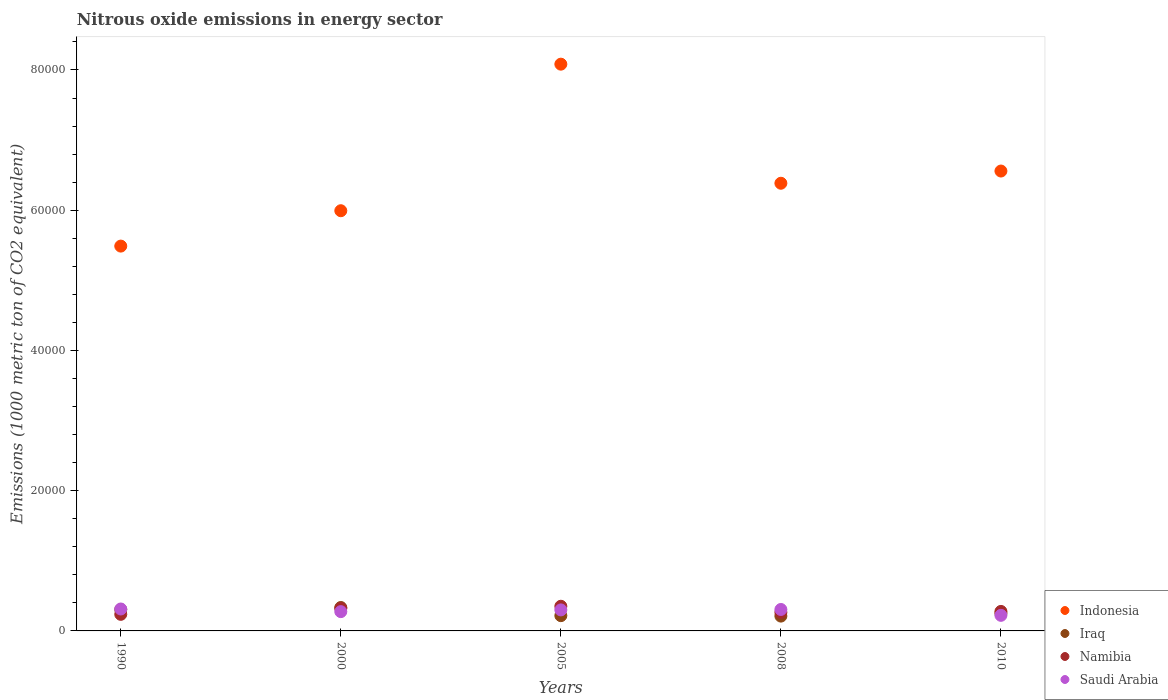Is the number of dotlines equal to the number of legend labels?
Make the answer very short. Yes. What is the amount of nitrous oxide emitted in Namibia in 2008?
Offer a terse response. 2645.5. Across all years, what is the maximum amount of nitrous oxide emitted in Iraq?
Your answer should be very brief. 3339.1. Across all years, what is the minimum amount of nitrous oxide emitted in Iraq?
Keep it short and to the point. 2113.2. What is the total amount of nitrous oxide emitted in Saudi Arabia in the graph?
Your answer should be compact. 1.42e+04. What is the difference between the amount of nitrous oxide emitted in Indonesia in 1990 and that in 2000?
Make the answer very short. -5044.7. What is the difference between the amount of nitrous oxide emitted in Indonesia in 2000 and the amount of nitrous oxide emitted in Iraq in 2008?
Make the answer very short. 5.78e+04. What is the average amount of nitrous oxide emitted in Indonesia per year?
Make the answer very short. 6.50e+04. In the year 2005, what is the difference between the amount of nitrous oxide emitted in Namibia and amount of nitrous oxide emitted in Iraq?
Offer a very short reply. 1340.8. What is the ratio of the amount of nitrous oxide emitted in Indonesia in 2000 to that in 2008?
Keep it short and to the point. 0.94. Is the difference between the amount of nitrous oxide emitted in Namibia in 2000 and 2010 greater than the difference between the amount of nitrous oxide emitted in Iraq in 2000 and 2010?
Offer a very short reply. No. What is the difference between the highest and the second highest amount of nitrous oxide emitted in Saudi Arabia?
Keep it short and to the point. 67.5. What is the difference between the highest and the lowest amount of nitrous oxide emitted in Indonesia?
Your answer should be compact. 2.59e+04. Is the sum of the amount of nitrous oxide emitted in Iraq in 2005 and 2010 greater than the maximum amount of nitrous oxide emitted in Indonesia across all years?
Make the answer very short. No. Is it the case that in every year, the sum of the amount of nitrous oxide emitted in Iraq and amount of nitrous oxide emitted in Namibia  is greater than the amount of nitrous oxide emitted in Saudi Arabia?
Provide a short and direct response. Yes. Does the amount of nitrous oxide emitted in Namibia monotonically increase over the years?
Your response must be concise. No. How many years are there in the graph?
Offer a terse response. 5. What is the difference between two consecutive major ticks on the Y-axis?
Provide a succinct answer. 2.00e+04. How are the legend labels stacked?
Offer a terse response. Vertical. What is the title of the graph?
Provide a short and direct response. Nitrous oxide emissions in energy sector. What is the label or title of the X-axis?
Make the answer very short. Years. What is the label or title of the Y-axis?
Offer a terse response. Emissions (1000 metric ton of CO2 equivalent). What is the Emissions (1000 metric ton of CO2 equivalent) of Indonesia in 1990?
Offer a terse response. 5.49e+04. What is the Emissions (1000 metric ton of CO2 equivalent) in Iraq in 1990?
Give a very brief answer. 3048.6. What is the Emissions (1000 metric ton of CO2 equivalent) in Namibia in 1990?
Provide a succinct answer. 2363.8. What is the Emissions (1000 metric ton of CO2 equivalent) in Saudi Arabia in 1990?
Your response must be concise. 3126.9. What is the Emissions (1000 metric ton of CO2 equivalent) in Indonesia in 2000?
Your answer should be compact. 5.99e+04. What is the Emissions (1000 metric ton of CO2 equivalent) in Iraq in 2000?
Provide a short and direct response. 3339.1. What is the Emissions (1000 metric ton of CO2 equivalent) in Namibia in 2000?
Give a very brief answer. 3218.7. What is the Emissions (1000 metric ton of CO2 equivalent) of Saudi Arabia in 2000?
Make the answer very short. 2750.6. What is the Emissions (1000 metric ton of CO2 equivalent) of Indonesia in 2005?
Offer a terse response. 8.08e+04. What is the Emissions (1000 metric ton of CO2 equivalent) in Iraq in 2005?
Your answer should be very brief. 2176. What is the Emissions (1000 metric ton of CO2 equivalent) in Namibia in 2005?
Offer a very short reply. 3516.8. What is the Emissions (1000 metric ton of CO2 equivalent) of Saudi Arabia in 2005?
Your answer should be very brief. 2996.3. What is the Emissions (1000 metric ton of CO2 equivalent) of Indonesia in 2008?
Make the answer very short. 6.38e+04. What is the Emissions (1000 metric ton of CO2 equivalent) of Iraq in 2008?
Your response must be concise. 2113.2. What is the Emissions (1000 metric ton of CO2 equivalent) of Namibia in 2008?
Offer a very short reply. 2645.5. What is the Emissions (1000 metric ton of CO2 equivalent) of Saudi Arabia in 2008?
Provide a short and direct response. 3059.4. What is the Emissions (1000 metric ton of CO2 equivalent) of Indonesia in 2010?
Your answer should be very brief. 6.56e+04. What is the Emissions (1000 metric ton of CO2 equivalent) in Iraq in 2010?
Ensure brevity in your answer.  2512.5. What is the Emissions (1000 metric ton of CO2 equivalent) of Namibia in 2010?
Provide a succinct answer. 2780.9. What is the Emissions (1000 metric ton of CO2 equivalent) of Saudi Arabia in 2010?
Your response must be concise. 2222.6. Across all years, what is the maximum Emissions (1000 metric ton of CO2 equivalent) in Indonesia?
Your response must be concise. 8.08e+04. Across all years, what is the maximum Emissions (1000 metric ton of CO2 equivalent) of Iraq?
Provide a short and direct response. 3339.1. Across all years, what is the maximum Emissions (1000 metric ton of CO2 equivalent) in Namibia?
Your answer should be compact. 3516.8. Across all years, what is the maximum Emissions (1000 metric ton of CO2 equivalent) of Saudi Arabia?
Provide a short and direct response. 3126.9. Across all years, what is the minimum Emissions (1000 metric ton of CO2 equivalent) of Indonesia?
Your answer should be compact. 5.49e+04. Across all years, what is the minimum Emissions (1000 metric ton of CO2 equivalent) of Iraq?
Your response must be concise. 2113.2. Across all years, what is the minimum Emissions (1000 metric ton of CO2 equivalent) of Namibia?
Your answer should be compact. 2363.8. Across all years, what is the minimum Emissions (1000 metric ton of CO2 equivalent) in Saudi Arabia?
Your answer should be very brief. 2222.6. What is the total Emissions (1000 metric ton of CO2 equivalent) in Indonesia in the graph?
Offer a terse response. 3.25e+05. What is the total Emissions (1000 metric ton of CO2 equivalent) of Iraq in the graph?
Offer a terse response. 1.32e+04. What is the total Emissions (1000 metric ton of CO2 equivalent) in Namibia in the graph?
Your answer should be compact. 1.45e+04. What is the total Emissions (1000 metric ton of CO2 equivalent) in Saudi Arabia in the graph?
Your answer should be very brief. 1.42e+04. What is the difference between the Emissions (1000 metric ton of CO2 equivalent) of Indonesia in 1990 and that in 2000?
Your answer should be very brief. -5044.7. What is the difference between the Emissions (1000 metric ton of CO2 equivalent) of Iraq in 1990 and that in 2000?
Offer a very short reply. -290.5. What is the difference between the Emissions (1000 metric ton of CO2 equivalent) in Namibia in 1990 and that in 2000?
Keep it short and to the point. -854.9. What is the difference between the Emissions (1000 metric ton of CO2 equivalent) of Saudi Arabia in 1990 and that in 2000?
Offer a very short reply. 376.3. What is the difference between the Emissions (1000 metric ton of CO2 equivalent) in Indonesia in 1990 and that in 2005?
Provide a short and direct response. -2.59e+04. What is the difference between the Emissions (1000 metric ton of CO2 equivalent) of Iraq in 1990 and that in 2005?
Your answer should be very brief. 872.6. What is the difference between the Emissions (1000 metric ton of CO2 equivalent) in Namibia in 1990 and that in 2005?
Your answer should be very brief. -1153. What is the difference between the Emissions (1000 metric ton of CO2 equivalent) in Saudi Arabia in 1990 and that in 2005?
Your answer should be compact. 130.6. What is the difference between the Emissions (1000 metric ton of CO2 equivalent) of Indonesia in 1990 and that in 2008?
Provide a short and direct response. -8962.8. What is the difference between the Emissions (1000 metric ton of CO2 equivalent) in Iraq in 1990 and that in 2008?
Your response must be concise. 935.4. What is the difference between the Emissions (1000 metric ton of CO2 equivalent) of Namibia in 1990 and that in 2008?
Give a very brief answer. -281.7. What is the difference between the Emissions (1000 metric ton of CO2 equivalent) of Saudi Arabia in 1990 and that in 2008?
Keep it short and to the point. 67.5. What is the difference between the Emissions (1000 metric ton of CO2 equivalent) of Indonesia in 1990 and that in 2010?
Your answer should be compact. -1.07e+04. What is the difference between the Emissions (1000 metric ton of CO2 equivalent) in Iraq in 1990 and that in 2010?
Make the answer very short. 536.1. What is the difference between the Emissions (1000 metric ton of CO2 equivalent) in Namibia in 1990 and that in 2010?
Provide a short and direct response. -417.1. What is the difference between the Emissions (1000 metric ton of CO2 equivalent) of Saudi Arabia in 1990 and that in 2010?
Give a very brief answer. 904.3. What is the difference between the Emissions (1000 metric ton of CO2 equivalent) in Indonesia in 2000 and that in 2005?
Offer a terse response. -2.09e+04. What is the difference between the Emissions (1000 metric ton of CO2 equivalent) in Iraq in 2000 and that in 2005?
Make the answer very short. 1163.1. What is the difference between the Emissions (1000 metric ton of CO2 equivalent) in Namibia in 2000 and that in 2005?
Ensure brevity in your answer.  -298.1. What is the difference between the Emissions (1000 metric ton of CO2 equivalent) in Saudi Arabia in 2000 and that in 2005?
Your answer should be very brief. -245.7. What is the difference between the Emissions (1000 metric ton of CO2 equivalent) in Indonesia in 2000 and that in 2008?
Ensure brevity in your answer.  -3918.1. What is the difference between the Emissions (1000 metric ton of CO2 equivalent) of Iraq in 2000 and that in 2008?
Your answer should be compact. 1225.9. What is the difference between the Emissions (1000 metric ton of CO2 equivalent) in Namibia in 2000 and that in 2008?
Offer a very short reply. 573.2. What is the difference between the Emissions (1000 metric ton of CO2 equivalent) in Saudi Arabia in 2000 and that in 2008?
Ensure brevity in your answer.  -308.8. What is the difference between the Emissions (1000 metric ton of CO2 equivalent) of Indonesia in 2000 and that in 2010?
Your answer should be very brief. -5659.3. What is the difference between the Emissions (1000 metric ton of CO2 equivalent) in Iraq in 2000 and that in 2010?
Your answer should be compact. 826.6. What is the difference between the Emissions (1000 metric ton of CO2 equivalent) of Namibia in 2000 and that in 2010?
Provide a short and direct response. 437.8. What is the difference between the Emissions (1000 metric ton of CO2 equivalent) in Saudi Arabia in 2000 and that in 2010?
Provide a succinct answer. 528. What is the difference between the Emissions (1000 metric ton of CO2 equivalent) of Indonesia in 2005 and that in 2008?
Make the answer very short. 1.70e+04. What is the difference between the Emissions (1000 metric ton of CO2 equivalent) in Iraq in 2005 and that in 2008?
Keep it short and to the point. 62.8. What is the difference between the Emissions (1000 metric ton of CO2 equivalent) of Namibia in 2005 and that in 2008?
Offer a very short reply. 871.3. What is the difference between the Emissions (1000 metric ton of CO2 equivalent) in Saudi Arabia in 2005 and that in 2008?
Make the answer very short. -63.1. What is the difference between the Emissions (1000 metric ton of CO2 equivalent) of Indonesia in 2005 and that in 2010?
Your response must be concise. 1.52e+04. What is the difference between the Emissions (1000 metric ton of CO2 equivalent) of Iraq in 2005 and that in 2010?
Offer a terse response. -336.5. What is the difference between the Emissions (1000 metric ton of CO2 equivalent) in Namibia in 2005 and that in 2010?
Your answer should be very brief. 735.9. What is the difference between the Emissions (1000 metric ton of CO2 equivalent) in Saudi Arabia in 2005 and that in 2010?
Give a very brief answer. 773.7. What is the difference between the Emissions (1000 metric ton of CO2 equivalent) of Indonesia in 2008 and that in 2010?
Your response must be concise. -1741.2. What is the difference between the Emissions (1000 metric ton of CO2 equivalent) of Iraq in 2008 and that in 2010?
Offer a terse response. -399.3. What is the difference between the Emissions (1000 metric ton of CO2 equivalent) in Namibia in 2008 and that in 2010?
Offer a terse response. -135.4. What is the difference between the Emissions (1000 metric ton of CO2 equivalent) in Saudi Arabia in 2008 and that in 2010?
Provide a succinct answer. 836.8. What is the difference between the Emissions (1000 metric ton of CO2 equivalent) of Indonesia in 1990 and the Emissions (1000 metric ton of CO2 equivalent) of Iraq in 2000?
Keep it short and to the point. 5.15e+04. What is the difference between the Emissions (1000 metric ton of CO2 equivalent) of Indonesia in 1990 and the Emissions (1000 metric ton of CO2 equivalent) of Namibia in 2000?
Provide a succinct answer. 5.17e+04. What is the difference between the Emissions (1000 metric ton of CO2 equivalent) in Indonesia in 1990 and the Emissions (1000 metric ton of CO2 equivalent) in Saudi Arabia in 2000?
Offer a terse response. 5.21e+04. What is the difference between the Emissions (1000 metric ton of CO2 equivalent) in Iraq in 1990 and the Emissions (1000 metric ton of CO2 equivalent) in Namibia in 2000?
Give a very brief answer. -170.1. What is the difference between the Emissions (1000 metric ton of CO2 equivalent) of Iraq in 1990 and the Emissions (1000 metric ton of CO2 equivalent) of Saudi Arabia in 2000?
Your answer should be very brief. 298. What is the difference between the Emissions (1000 metric ton of CO2 equivalent) in Namibia in 1990 and the Emissions (1000 metric ton of CO2 equivalent) in Saudi Arabia in 2000?
Your answer should be very brief. -386.8. What is the difference between the Emissions (1000 metric ton of CO2 equivalent) of Indonesia in 1990 and the Emissions (1000 metric ton of CO2 equivalent) of Iraq in 2005?
Your response must be concise. 5.27e+04. What is the difference between the Emissions (1000 metric ton of CO2 equivalent) of Indonesia in 1990 and the Emissions (1000 metric ton of CO2 equivalent) of Namibia in 2005?
Offer a terse response. 5.14e+04. What is the difference between the Emissions (1000 metric ton of CO2 equivalent) in Indonesia in 1990 and the Emissions (1000 metric ton of CO2 equivalent) in Saudi Arabia in 2005?
Make the answer very short. 5.19e+04. What is the difference between the Emissions (1000 metric ton of CO2 equivalent) in Iraq in 1990 and the Emissions (1000 metric ton of CO2 equivalent) in Namibia in 2005?
Provide a succinct answer. -468.2. What is the difference between the Emissions (1000 metric ton of CO2 equivalent) in Iraq in 1990 and the Emissions (1000 metric ton of CO2 equivalent) in Saudi Arabia in 2005?
Keep it short and to the point. 52.3. What is the difference between the Emissions (1000 metric ton of CO2 equivalent) of Namibia in 1990 and the Emissions (1000 metric ton of CO2 equivalent) of Saudi Arabia in 2005?
Your answer should be compact. -632.5. What is the difference between the Emissions (1000 metric ton of CO2 equivalent) in Indonesia in 1990 and the Emissions (1000 metric ton of CO2 equivalent) in Iraq in 2008?
Offer a very short reply. 5.28e+04. What is the difference between the Emissions (1000 metric ton of CO2 equivalent) of Indonesia in 1990 and the Emissions (1000 metric ton of CO2 equivalent) of Namibia in 2008?
Provide a short and direct response. 5.22e+04. What is the difference between the Emissions (1000 metric ton of CO2 equivalent) in Indonesia in 1990 and the Emissions (1000 metric ton of CO2 equivalent) in Saudi Arabia in 2008?
Your response must be concise. 5.18e+04. What is the difference between the Emissions (1000 metric ton of CO2 equivalent) in Iraq in 1990 and the Emissions (1000 metric ton of CO2 equivalent) in Namibia in 2008?
Ensure brevity in your answer.  403.1. What is the difference between the Emissions (1000 metric ton of CO2 equivalent) in Namibia in 1990 and the Emissions (1000 metric ton of CO2 equivalent) in Saudi Arabia in 2008?
Give a very brief answer. -695.6. What is the difference between the Emissions (1000 metric ton of CO2 equivalent) of Indonesia in 1990 and the Emissions (1000 metric ton of CO2 equivalent) of Iraq in 2010?
Offer a terse response. 5.24e+04. What is the difference between the Emissions (1000 metric ton of CO2 equivalent) of Indonesia in 1990 and the Emissions (1000 metric ton of CO2 equivalent) of Namibia in 2010?
Your answer should be very brief. 5.21e+04. What is the difference between the Emissions (1000 metric ton of CO2 equivalent) in Indonesia in 1990 and the Emissions (1000 metric ton of CO2 equivalent) in Saudi Arabia in 2010?
Provide a succinct answer. 5.27e+04. What is the difference between the Emissions (1000 metric ton of CO2 equivalent) of Iraq in 1990 and the Emissions (1000 metric ton of CO2 equivalent) of Namibia in 2010?
Ensure brevity in your answer.  267.7. What is the difference between the Emissions (1000 metric ton of CO2 equivalent) of Iraq in 1990 and the Emissions (1000 metric ton of CO2 equivalent) of Saudi Arabia in 2010?
Your answer should be very brief. 826. What is the difference between the Emissions (1000 metric ton of CO2 equivalent) in Namibia in 1990 and the Emissions (1000 metric ton of CO2 equivalent) in Saudi Arabia in 2010?
Your answer should be compact. 141.2. What is the difference between the Emissions (1000 metric ton of CO2 equivalent) in Indonesia in 2000 and the Emissions (1000 metric ton of CO2 equivalent) in Iraq in 2005?
Keep it short and to the point. 5.78e+04. What is the difference between the Emissions (1000 metric ton of CO2 equivalent) in Indonesia in 2000 and the Emissions (1000 metric ton of CO2 equivalent) in Namibia in 2005?
Keep it short and to the point. 5.64e+04. What is the difference between the Emissions (1000 metric ton of CO2 equivalent) of Indonesia in 2000 and the Emissions (1000 metric ton of CO2 equivalent) of Saudi Arabia in 2005?
Offer a very short reply. 5.69e+04. What is the difference between the Emissions (1000 metric ton of CO2 equivalent) in Iraq in 2000 and the Emissions (1000 metric ton of CO2 equivalent) in Namibia in 2005?
Keep it short and to the point. -177.7. What is the difference between the Emissions (1000 metric ton of CO2 equivalent) of Iraq in 2000 and the Emissions (1000 metric ton of CO2 equivalent) of Saudi Arabia in 2005?
Your answer should be very brief. 342.8. What is the difference between the Emissions (1000 metric ton of CO2 equivalent) in Namibia in 2000 and the Emissions (1000 metric ton of CO2 equivalent) in Saudi Arabia in 2005?
Offer a terse response. 222.4. What is the difference between the Emissions (1000 metric ton of CO2 equivalent) of Indonesia in 2000 and the Emissions (1000 metric ton of CO2 equivalent) of Iraq in 2008?
Ensure brevity in your answer.  5.78e+04. What is the difference between the Emissions (1000 metric ton of CO2 equivalent) in Indonesia in 2000 and the Emissions (1000 metric ton of CO2 equivalent) in Namibia in 2008?
Offer a terse response. 5.73e+04. What is the difference between the Emissions (1000 metric ton of CO2 equivalent) of Indonesia in 2000 and the Emissions (1000 metric ton of CO2 equivalent) of Saudi Arabia in 2008?
Your answer should be compact. 5.69e+04. What is the difference between the Emissions (1000 metric ton of CO2 equivalent) in Iraq in 2000 and the Emissions (1000 metric ton of CO2 equivalent) in Namibia in 2008?
Give a very brief answer. 693.6. What is the difference between the Emissions (1000 metric ton of CO2 equivalent) of Iraq in 2000 and the Emissions (1000 metric ton of CO2 equivalent) of Saudi Arabia in 2008?
Provide a short and direct response. 279.7. What is the difference between the Emissions (1000 metric ton of CO2 equivalent) of Namibia in 2000 and the Emissions (1000 metric ton of CO2 equivalent) of Saudi Arabia in 2008?
Your response must be concise. 159.3. What is the difference between the Emissions (1000 metric ton of CO2 equivalent) of Indonesia in 2000 and the Emissions (1000 metric ton of CO2 equivalent) of Iraq in 2010?
Your answer should be compact. 5.74e+04. What is the difference between the Emissions (1000 metric ton of CO2 equivalent) of Indonesia in 2000 and the Emissions (1000 metric ton of CO2 equivalent) of Namibia in 2010?
Your answer should be compact. 5.71e+04. What is the difference between the Emissions (1000 metric ton of CO2 equivalent) of Indonesia in 2000 and the Emissions (1000 metric ton of CO2 equivalent) of Saudi Arabia in 2010?
Ensure brevity in your answer.  5.77e+04. What is the difference between the Emissions (1000 metric ton of CO2 equivalent) in Iraq in 2000 and the Emissions (1000 metric ton of CO2 equivalent) in Namibia in 2010?
Ensure brevity in your answer.  558.2. What is the difference between the Emissions (1000 metric ton of CO2 equivalent) in Iraq in 2000 and the Emissions (1000 metric ton of CO2 equivalent) in Saudi Arabia in 2010?
Offer a terse response. 1116.5. What is the difference between the Emissions (1000 metric ton of CO2 equivalent) of Namibia in 2000 and the Emissions (1000 metric ton of CO2 equivalent) of Saudi Arabia in 2010?
Your response must be concise. 996.1. What is the difference between the Emissions (1000 metric ton of CO2 equivalent) of Indonesia in 2005 and the Emissions (1000 metric ton of CO2 equivalent) of Iraq in 2008?
Your answer should be very brief. 7.87e+04. What is the difference between the Emissions (1000 metric ton of CO2 equivalent) in Indonesia in 2005 and the Emissions (1000 metric ton of CO2 equivalent) in Namibia in 2008?
Your answer should be very brief. 7.82e+04. What is the difference between the Emissions (1000 metric ton of CO2 equivalent) in Indonesia in 2005 and the Emissions (1000 metric ton of CO2 equivalent) in Saudi Arabia in 2008?
Offer a very short reply. 7.78e+04. What is the difference between the Emissions (1000 metric ton of CO2 equivalent) in Iraq in 2005 and the Emissions (1000 metric ton of CO2 equivalent) in Namibia in 2008?
Offer a terse response. -469.5. What is the difference between the Emissions (1000 metric ton of CO2 equivalent) in Iraq in 2005 and the Emissions (1000 metric ton of CO2 equivalent) in Saudi Arabia in 2008?
Provide a succinct answer. -883.4. What is the difference between the Emissions (1000 metric ton of CO2 equivalent) of Namibia in 2005 and the Emissions (1000 metric ton of CO2 equivalent) of Saudi Arabia in 2008?
Keep it short and to the point. 457.4. What is the difference between the Emissions (1000 metric ton of CO2 equivalent) of Indonesia in 2005 and the Emissions (1000 metric ton of CO2 equivalent) of Iraq in 2010?
Your answer should be very brief. 7.83e+04. What is the difference between the Emissions (1000 metric ton of CO2 equivalent) of Indonesia in 2005 and the Emissions (1000 metric ton of CO2 equivalent) of Namibia in 2010?
Your answer should be compact. 7.80e+04. What is the difference between the Emissions (1000 metric ton of CO2 equivalent) in Indonesia in 2005 and the Emissions (1000 metric ton of CO2 equivalent) in Saudi Arabia in 2010?
Make the answer very short. 7.86e+04. What is the difference between the Emissions (1000 metric ton of CO2 equivalent) of Iraq in 2005 and the Emissions (1000 metric ton of CO2 equivalent) of Namibia in 2010?
Offer a terse response. -604.9. What is the difference between the Emissions (1000 metric ton of CO2 equivalent) of Iraq in 2005 and the Emissions (1000 metric ton of CO2 equivalent) of Saudi Arabia in 2010?
Keep it short and to the point. -46.6. What is the difference between the Emissions (1000 metric ton of CO2 equivalent) in Namibia in 2005 and the Emissions (1000 metric ton of CO2 equivalent) in Saudi Arabia in 2010?
Provide a succinct answer. 1294.2. What is the difference between the Emissions (1000 metric ton of CO2 equivalent) of Indonesia in 2008 and the Emissions (1000 metric ton of CO2 equivalent) of Iraq in 2010?
Your answer should be compact. 6.13e+04. What is the difference between the Emissions (1000 metric ton of CO2 equivalent) of Indonesia in 2008 and the Emissions (1000 metric ton of CO2 equivalent) of Namibia in 2010?
Provide a short and direct response. 6.11e+04. What is the difference between the Emissions (1000 metric ton of CO2 equivalent) in Indonesia in 2008 and the Emissions (1000 metric ton of CO2 equivalent) in Saudi Arabia in 2010?
Your response must be concise. 6.16e+04. What is the difference between the Emissions (1000 metric ton of CO2 equivalent) in Iraq in 2008 and the Emissions (1000 metric ton of CO2 equivalent) in Namibia in 2010?
Keep it short and to the point. -667.7. What is the difference between the Emissions (1000 metric ton of CO2 equivalent) in Iraq in 2008 and the Emissions (1000 metric ton of CO2 equivalent) in Saudi Arabia in 2010?
Your answer should be compact. -109.4. What is the difference between the Emissions (1000 metric ton of CO2 equivalent) in Namibia in 2008 and the Emissions (1000 metric ton of CO2 equivalent) in Saudi Arabia in 2010?
Your response must be concise. 422.9. What is the average Emissions (1000 metric ton of CO2 equivalent) of Indonesia per year?
Keep it short and to the point. 6.50e+04. What is the average Emissions (1000 metric ton of CO2 equivalent) in Iraq per year?
Your answer should be compact. 2637.88. What is the average Emissions (1000 metric ton of CO2 equivalent) in Namibia per year?
Provide a succinct answer. 2905.14. What is the average Emissions (1000 metric ton of CO2 equivalent) in Saudi Arabia per year?
Your answer should be compact. 2831.16. In the year 1990, what is the difference between the Emissions (1000 metric ton of CO2 equivalent) in Indonesia and Emissions (1000 metric ton of CO2 equivalent) in Iraq?
Your response must be concise. 5.18e+04. In the year 1990, what is the difference between the Emissions (1000 metric ton of CO2 equivalent) of Indonesia and Emissions (1000 metric ton of CO2 equivalent) of Namibia?
Give a very brief answer. 5.25e+04. In the year 1990, what is the difference between the Emissions (1000 metric ton of CO2 equivalent) of Indonesia and Emissions (1000 metric ton of CO2 equivalent) of Saudi Arabia?
Provide a short and direct response. 5.18e+04. In the year 1990, what is the difference between the Emissions (1000 metric ton of CO2 equivalent) of Iraq and Emissions (1000 metric ton of CO2 equivalent) of Namibia?
Provide a short and direct response. 684.8. In the year 1990, what is the difference between the Emissions (1000 metric ton of CO2 equivalent) in Iraq and Emissions (1000 metric ton of CO2 equivalent) in Saudi Arabia?
Make the answer very short. -78.3. In the year 1990, what is the difference between the Emissions (1000 metric ton of CO2 equivalent) in Namibia and Emissions (1000 metric ton of CO2 equivalent) in Saudi Arabia?
Give a very brief answer. -763.1. In the year 2000, what is the difference between the Emissions (1000 metric ton of CO2 equivalent) of Indonesia and Emissions (1000 metric ton of CO2 equivalent) of Iraq?
Your answer should be compact. 5.66e+04. In the year 2000, what is the difference between the Emissions (1000 metric ton of CO2 equivalent) in Indonesia and Emissions (1000 metric ton of CO2 equivalent) in Namibia?
Ensure brevity in your answer.  5.67e+04. In the year 2000, what is the difference between the Emissions (1000 metric ton of CO2 equivalent) of Indonesia and Emissions (1000 metric ton of CO2 equivalent) of Saudi Arabia?
Give a very brief answer. 5.72e+04. In the year 2000, what is the difference between the Emissions (1000 metric ton of CO2 equivalent) in Iraq and Emissions (1000 metric ton of CO2 equivalent) in Namibia?
Provide a short and direct response. 120.4. In the year 2000, what is the difference between the Emissions (1000 metric ton of CO2 equivalent) of Iraq and Emissions (1000 metric ton of CO2 equivalent) of Saudi Arabia?
Offer a very short reply. 588.5. In the year 2000, what is the difference between the Emissions (1000 metric ton of CO2 equivalent) of Namibia and Emissions (1000 metric ton of CO2 equivalent) of Saudi Arabia?
Offer a very short reply. 468.1. In the year 2005, what is the difference between the Emissions (1000 metric ton of CO2 equivalent) of Indonesia and Emissions (1000 metric ton of CO2 equivalent) of Iraq?
Your answer should be very brief. 7.87e+04. In the year 2005, what is the difference between the Emissions (1000 metric ton of CO2 equivalent) in Indonesia and Emissions (1000 metric ton of CO2 equivalent) in Namibia?
Offer a very short reply. 7.73e+04. In the year 2005, what is the difference between the Emissions (1000 metric ton of CO2 equivalent) in Indonesia and Emissions (1000 metric ton of CO2 equivalent) in Saudi Arabia?
Keep it short and to the point. 7.78e+04. In the year 2005, what is the difference between the Emissions (1000 metric ton of CO2 equivalent) of Iraq and Emissions (1000 metric ton of CO2 equivalent) of Namibia?
Offer a terse response. -1340.8. In the year 2005, what is the difference between the Emissions (1000 metric ton of CO2 equivalent) of Iraq and Emissions (1000 metric ton of CO2 equivalent) of Saudi Arabia?
Ensure brevity in your answer.  -820.3. In the year 2005, what is the difference between the Emissions (1000 metric ton of CO2 equivalent) in Namibia and Emissions (1000 metric ton of CO2 equivalent) in Saudi Arabia?
Your answer should be compact. 520.5. In the year 2008, what is the difference between the Emissions (1000 metric ton of CO2 equivalent) in Indonesia and Emissions (1000 metric ton of CO2 equivalent) in Iraq?
Offer a very short reply. 6.17e+04. In the year 2008, what is the difference between the Emissions (1000 metric ton of CO2 equivalent) of Indonesia and Emissions (1000 metric ton of CO2 equivalent) of Namibia?
Offer a terse response. 6.12e+04. In the year 2008, what is the difference between the Emissions (1000 metric ton of CO2 equivalent) in Indonesia and Emissions (1000 metric ton of CO2 equivalent) in Saudi Arabia?
Make the answer very short. 6.08e+04. In the year 2008, what is the difference between the Emissions (1000 metric ton of CO2 equivalent) in Iraq and Emissions (1000 metric ton of CO2 equivalent) in Namibia?
Provide a short and direct response. -532.3. In the year 2008, what is the difference between the Emissions (1000 metric ton of CO2 equivalent) in Iraq and Emissions (1000 metric ton of CO2 equivalent) in Saudi Arabia?
Your answer should be very brief. -946.2. In the year 2008, what is the difference between the Emissions (1000 metric ton of CO2 equivalent) in Namibia and Emissions (1000 metric ton of CO2 equivalent) in Saudi Arabia?
Make the answer very short. -413.9. In the year 2010, what is the difference between the Emissions (1000 metric ton of CO2 equivalent) of Indonesia and Emissions (1000 metric ton of CO2 equivalent) of Iraq?
Provide a succinct answer. 6.31e+04. In the year 2010, what is the difference between the Emissions (1000 metric ton of CO2 equivalent) in Indonesia and Emissions (1000 metric ton of CO2 equivalent) in Namibia?
Offer a very short reply. 6.28e+04. In the year 2010, what is the difference between the Emissions (1000 metric ton of CO2 equivalent) in Indonesia and Emissions (1000 metric ton of CO2 equivalent) in Saudi Arabia?
Give a very brief answer. 6.34e+04. In the year 2010, what is the difference between the Emissions (1000 metric ton of CO2 equivalent) of Iraq and Emissions (1000 metric ton of CO2 equivalent) of Namibia?
Ensure brevity in your answer.  -268.4. In the year 2010, what is the difference between the Emissions (1000 metric ton of CO2 equivalent) of Iraq and Emissions (1000 metric ton of CO2 equivalent) of Saudi Arabia?
Offer a terse response. 289.9. In the year 2010, what is the difference between the Emissions (1000 metric ton of CO2 equivalent) in Namibia and Emissions (1000 metric ton of CO2 equivalent) in Saudi Arabia?
Your answer should be very brief. 558.3. What is the ratio of the Emissions (1000 metric ton of CO2 equivalent) in Indonesia in 1990 to that in 2000?
Make the answer very short. 0.92. What is the ratio of the Emissions (1000 metric ton of CO2 equivalent) in Iraq in 1990 to that in 2000?
Offer a terse response. 0.91. What is the ratio of the Emissions (1000 metric ton of CO2 equivalent) of Namibia in 1990 to that in 2000?
Your answer should be very brief. 0.73. What is the ratio of the Emissions (1000 metric ton of CO2 equivalent) in Saudi Arabia in 1990 to that in 2000?
Make the answer very short. 1.14. What is the ratio of the Emissions (1000 metric ton of CO2 equivalent) of Indonesia in 1990 to that in 2005?
Offer a very short reply. 0.68. What is the ratio of the Emissions (1000 metric ton of CO2 equivalent) in Iraq in 1990 to that in 2005?
Keep it short and to the point. 1.4. What is the ratio of the Emissions (1000 metric ton of CO2 equivalent) in Namibia in 1990 to that in 2005?
Offer a terse response. 0.67. What is the ratio of the Emissions (1000 metric ton of CO2 equivalent) in Saudi Arabia in 1990 to that in 2005?
Your answer should be very brief. 1.04. What is the ratio of the Emissions (1000 metric ton of CO2 equivalent) in Indonesia in 1990 to that in 2008?
Offer a terse response. 0.86. What is the ratio of the Emissions (1000 metric ton of CO2 equivalent) in Iraq in 1990 to that in 2008?
Keep it short and to the point. 1.44. What is the ratio of the Emissions (1000 metric ton of CO2 equivalent) of Namibia in 1990 to that in 2008?
Provide a succinct answer. 0.89. What is the ratio of the Emissions (1000 metric ton of CO2 equivalent) of Saudi Arabia in 1990 to that in 2008?
Give a very brief answer. 1.02. What is the ratio of the Emissions (1000 metric ton of CO2 equivalent) of Indonesia in 1990 to that in 2010?
Provide a short and direct response. 0.84. What is the ratio of the Emissions (1000 metric ton of CO2 equivalent) of Iraq in 1990 to that in 2010?
Provide a succinct answer. 1.21. What is the ratio of the Emissions (1000 metric ton of CO2 equivalent) of Saudi Arabia in 1990 to that in 2010?
Provide a short and direct response. 1.41. What is the ratio of the Emissions (1000 metric ton of CO2 equivalent) of Indonesia in 2000 to that in 2005?
Provide a succinct answer. 0.74. What is the ratio of the Emissions (1000 metric ton of CO2 equivalent) of Iraq in 2000 to that in 2005?
Keep it short and to the point. 1.53. What is the ratio of the Emissions (1000 metric ton of CO2 equivalent) in Namibia in 2000 to that in 2005?
Your answer should be very brief. 0.92. What is the ratio of the Emissions (1000 metric ton of CO2 equivalent) of Saudi Arabia in 2000 to that in 2005?
Your answer should be compact. 0.92. What is the ratio of the Emissions (1000 metric ton of CO2 equivalent) of Indonesia in 2000 to that in 2008?
Ensure brevity in your answer.  0.94. What is the ratio of the Emissions (1000 metric ton of CO2 equivalent) of Iraq in 2000 to that in 2008?
Offer a very short reply. 1.58. What is the ratio of the Emissions (1000 metric ton of CO2 equivalent) in Namibia in 2000 to that in 2008?
Keep it short and to the point. 1.22. What is the ratio of the Emissions (1000 metric ton of CO2 equivalent) in Saudi Arabia in 2000 to that in 2008?
Offer a very short reply. 0.9. What is the ratio of the Emissions (1000 metric ton of CO2 equivalent) of Indonesia in 2000 to that in 2010?
Provide a succinct answer. 0.91. What is the ratio of the Emissions (1000 metric ton of CO2 equivalent) of Iraq in 2000 to that in 2010?
Ensure brevity in your answer.  1.33. What is the ratio of the Emissions (1000 metric ton of CO2 equivalent) of Namibia in 2000 to that in 2010?
Your answer should be compact. 1.16. What is the ratio of the Emissions (1000 metric ton of CO2 equivalent) in Saudi Arabia in 2000 to that in 2010?
Give a very brief answer. 1.24. What is the ratio of the Emissions (1000 metric ton of CO2 equivalent) of Indonesia in 2005 to that in 2008?
Your answer should be very brief. 1.27. What is the ratio of the Emissions (1000 metric ton of CO2 equivalent) of Iraq in 2005 to that in 2008?
Ensure brevity in your answer.  1.03. What is the ratio of the Emissions (1000 metric ton of CO2 equivalent) of Namibia in 2005 to that in 2008?
Your response must be concise. 1.33. What is the ratio of the Emissions (1000 metric ton of CO2 equivalent) in Saudi Arabia in 2005 to that in 2008?
Your answer should be compact. 0.98. What is the ratio of the Emissions (1000 metric ton of CO2 equivalent) of Indonesia in 2005 to that in 2010?
Ensure brevity in your answer.  1.23. What is the ratio of the Emissions (1000 metric ton of CO2 equivalent) in Iraq in 2005 to that in 2010?
Your answer should be very brief. 0.87. What is the ratio of the Emissions (1000 metric ton of CO2 equivalent) of Namibia in 2005 to that in 2010?
Ensure brevity in your answer.  1.26. What is the ratio of the Emissions (1000 metric ton of CO2 equivalent) of Saudi Arabia in 2005 to that in 2010?
Your response must be concise. 1.35. What is the ratio of the Emissions (1000 metric ton of CO2 equivalent) of Indonesia in 2008 to that in 2010?
Keep it short and to the point. 0.97. What is the ratio of the Emissions (1000 metric ton of CO2 equivalent) in Iraq in 2008 to that in 2010?
Provide a succinct answer. 0.84. What is the ratio of the Emissions (1000 metric ton of CO2 equivalent) of Namibia in 2008 to that in 2010?
Give a very brief answer. 0.95. What is the ratio of the Emissions (1000 metric ton of CO2 equivalent) in Saudi Arabia in 2008 to that in 2010?
Give a very brief answer. 1.38. What is the difference between the highest and the second highest Emissions (1000 metric ton of CO2 equivalent) in Indonesia?
Keep it short and to the point. 1.52e+04. What is the difference between the highest and the second highest Emissions (1000 metric ton of CO2 equivalent) of Iraq?
Offer a terse response. 290.5. What is the difference between the highest and the second highest Emissions (1000 metric ton of CO2 equivalent) of Namibia?
Keep it short and to the point. 298.1. What is the difference between the highest and the second highest Emissions (1000 metric ton of CO2 equivalent) of Saudi Arabia?
Provide a short and direct response. 67.5. What is the difference between the highest and the lowest Emissions (1000 metric ton of CO2 equivalent) of Indonesia?
Provide a succinct answer. 2.59e+04. What is the difference between the highest and the lowest Emissions (1000 metric ton of CO2 equivalent) of Iraq?
Your answer should be very brief. 1225.9. What is the difference between the highest and the lowest Emissions (1000 metric ton of CO2 equivalent) in Namibia?
Make the answer very short. 1153. What is the difference between the highest and the lowest Emissions (1000 metric ton of CO2 equivalent) in Saudi Arabia?
Ensure brevity in your answer.  904.3. 